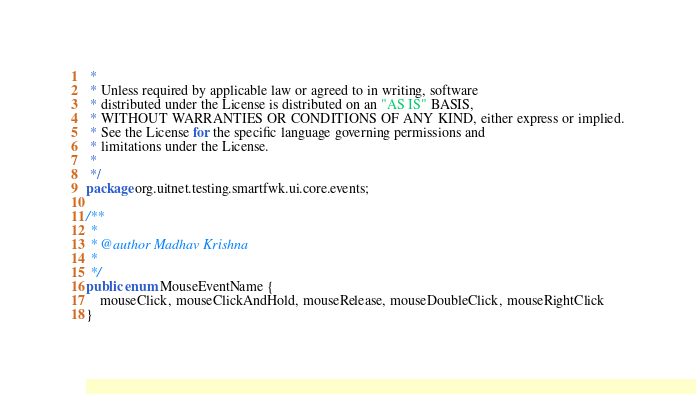Convert code to text. <code><loc_0><loc_0><loc_500><loc_500><_Java_> * 
 * Unless required by applicable law or agreed to in writing, software
 * distributed under the License is distributed on an "AS IS" BASIS,
 * WITHOUT WARRANTIES OR CONDITIONS OF ANY KIND, either express or implied.
 * See the License for the specific language governing permissions and
 * limitations under the License.
 * 
 */
package org.uitnet.testing.smartfwk.ui.core.events;

/**
 * 
 * @author Madhav Krishna
 *
 */
public enum MouseEventName {
	mouseClick, mouseClickAndHold, mouseRelease, mouseDoubleClick, mouseRightClick
}
</code> 